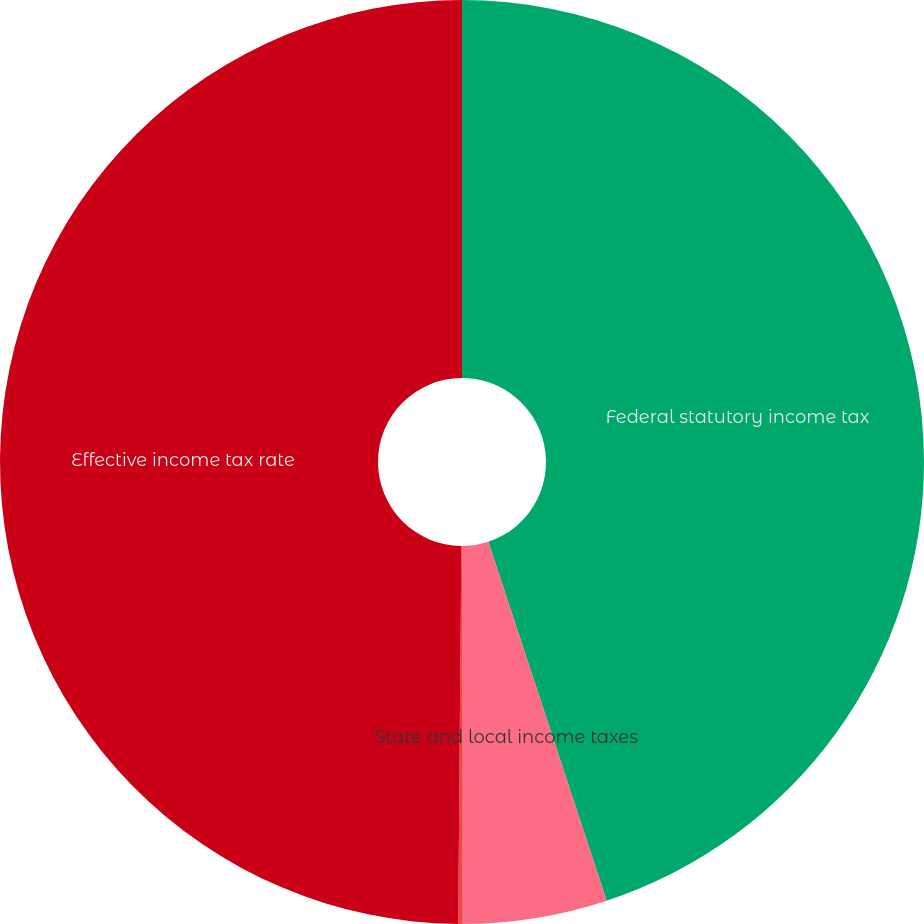<chart> <loc_0><loc_0><loc_500><loc_500><pie_chart><fcel>Federal statutory income tax<fcel>State and local income taxes<fcel>Nondeductible items<fcel>Effective income tax rate<nl><fcel>44.93%<fcel>5.07%<fcel>0.13%<fcel>49.87%<nl></chart> 